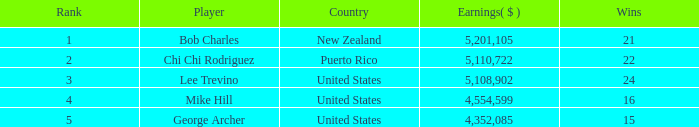How many wins, on average, possess a rank lower than 1? None. 